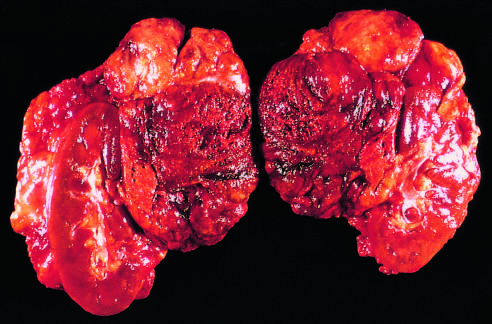what is there in addition to loss of all but a subcapsular rim of cortical cells?
Answer the question using a single word or phrase. Extensive mononuclear cell infiltrate 